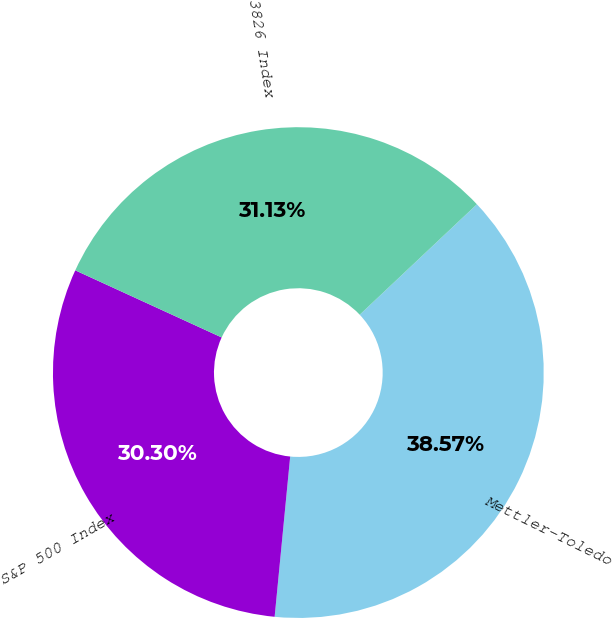Convert chart. <chart><loc_0><loc_0><loc_500><loc_500><pie_chart><fcel>Mettler-Toledo<fcel>S&P 500 Index<fcel>SIC Code 3826 Index<nl><fcel>38.57%<fcel>30.3%<fcel>31.13%<nl></chart> 